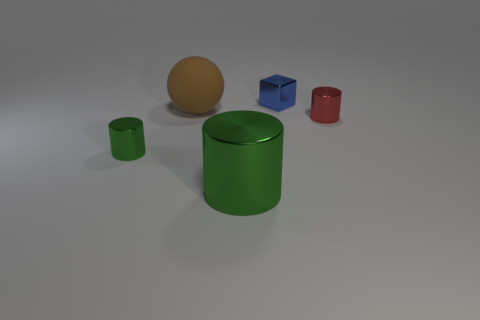In this task, you will be presented with an image containing 3D-rendered objects along with a set of questions and corresponding answers. Your goal is to correctly match each question with its corresponding answer based on the visual content of the image. The output format should follow this pattern: Q1A3, Q2A5, Q3A2, Q4A1, Q5A1, indicating the question number followed by the corresponding answer number.

Q1: Is there a green cylinder made of the same material as the blue thing?
Q2: The block that is made of the same material as the large cylinder is what color?
Q3: There is a large object behind the small green metallic cylinder; what material is it?
Q4: What is the shape of the blue thing?
Q5: What number of things are big brown things or large purple rubber blocks?
Q6: Are there more big cylinders to the left of the tiny red metal cylinder than red metal things behind the brown matte sphere?
Q7: Do the green cylinder that is to the left of the brown thing and the big green thing have the same size?
Q8: There is a shiny cube that is the same size as the red shiny object; what is its color?
Q9: Are any red metal cylinders visible?
A1: no
A2: 1
A3: blue
A4: yes
A5: cube
A6: rubber Based on the visual content of the image and the questions provided:

Q1: Is there a green cylinder made of the same material as the blue thing? (A4: yes, they both have a shiny appearance)
Q2: The block that is made of the same material as the large cylinder is what color? (A3: blue, as it has a similar shiny appearance to the green cylinder)
Q3: There is a large object behind the small green metallic cylinder; what material is it? (A6: rubber, assuming the matte brown sphere is considered rubber in contrast to the shiny materials)
Q4: What is the shape of the blue thing? (A5: cube)
Q5: What number of things are big brown things or large purple rubber blocks? (A2: 1, only the brown sphere is big and there are no purple blocks)
Q6: Are there more big cylinders to the left of the tiny red metal cylinder than red metal things behind the brown matte sphere? (A1: no, there is only one small green cylinder to the left of the red cylinder and no red objects behind the brown sphere)
Q7: Do the green cylinder that is to the left of the brown thing and the big green thing have the same size? (A1: no, they are different sizes)
Q8: There is a shiny cube that is the same size as the red shiny object; what is its color? (A3: blue, as both the cube and the red cylinder are small and shiny)
Q9: Are any red metal cylinders visible? (A4: yes, there is one small red cylinder)

Therefore, the answers are matched as follows: Q1A4, Q2A3, Q3A6, Q4A5, Q5A2, Q6A1, Q7A1, Q8A3, Q9A4. 